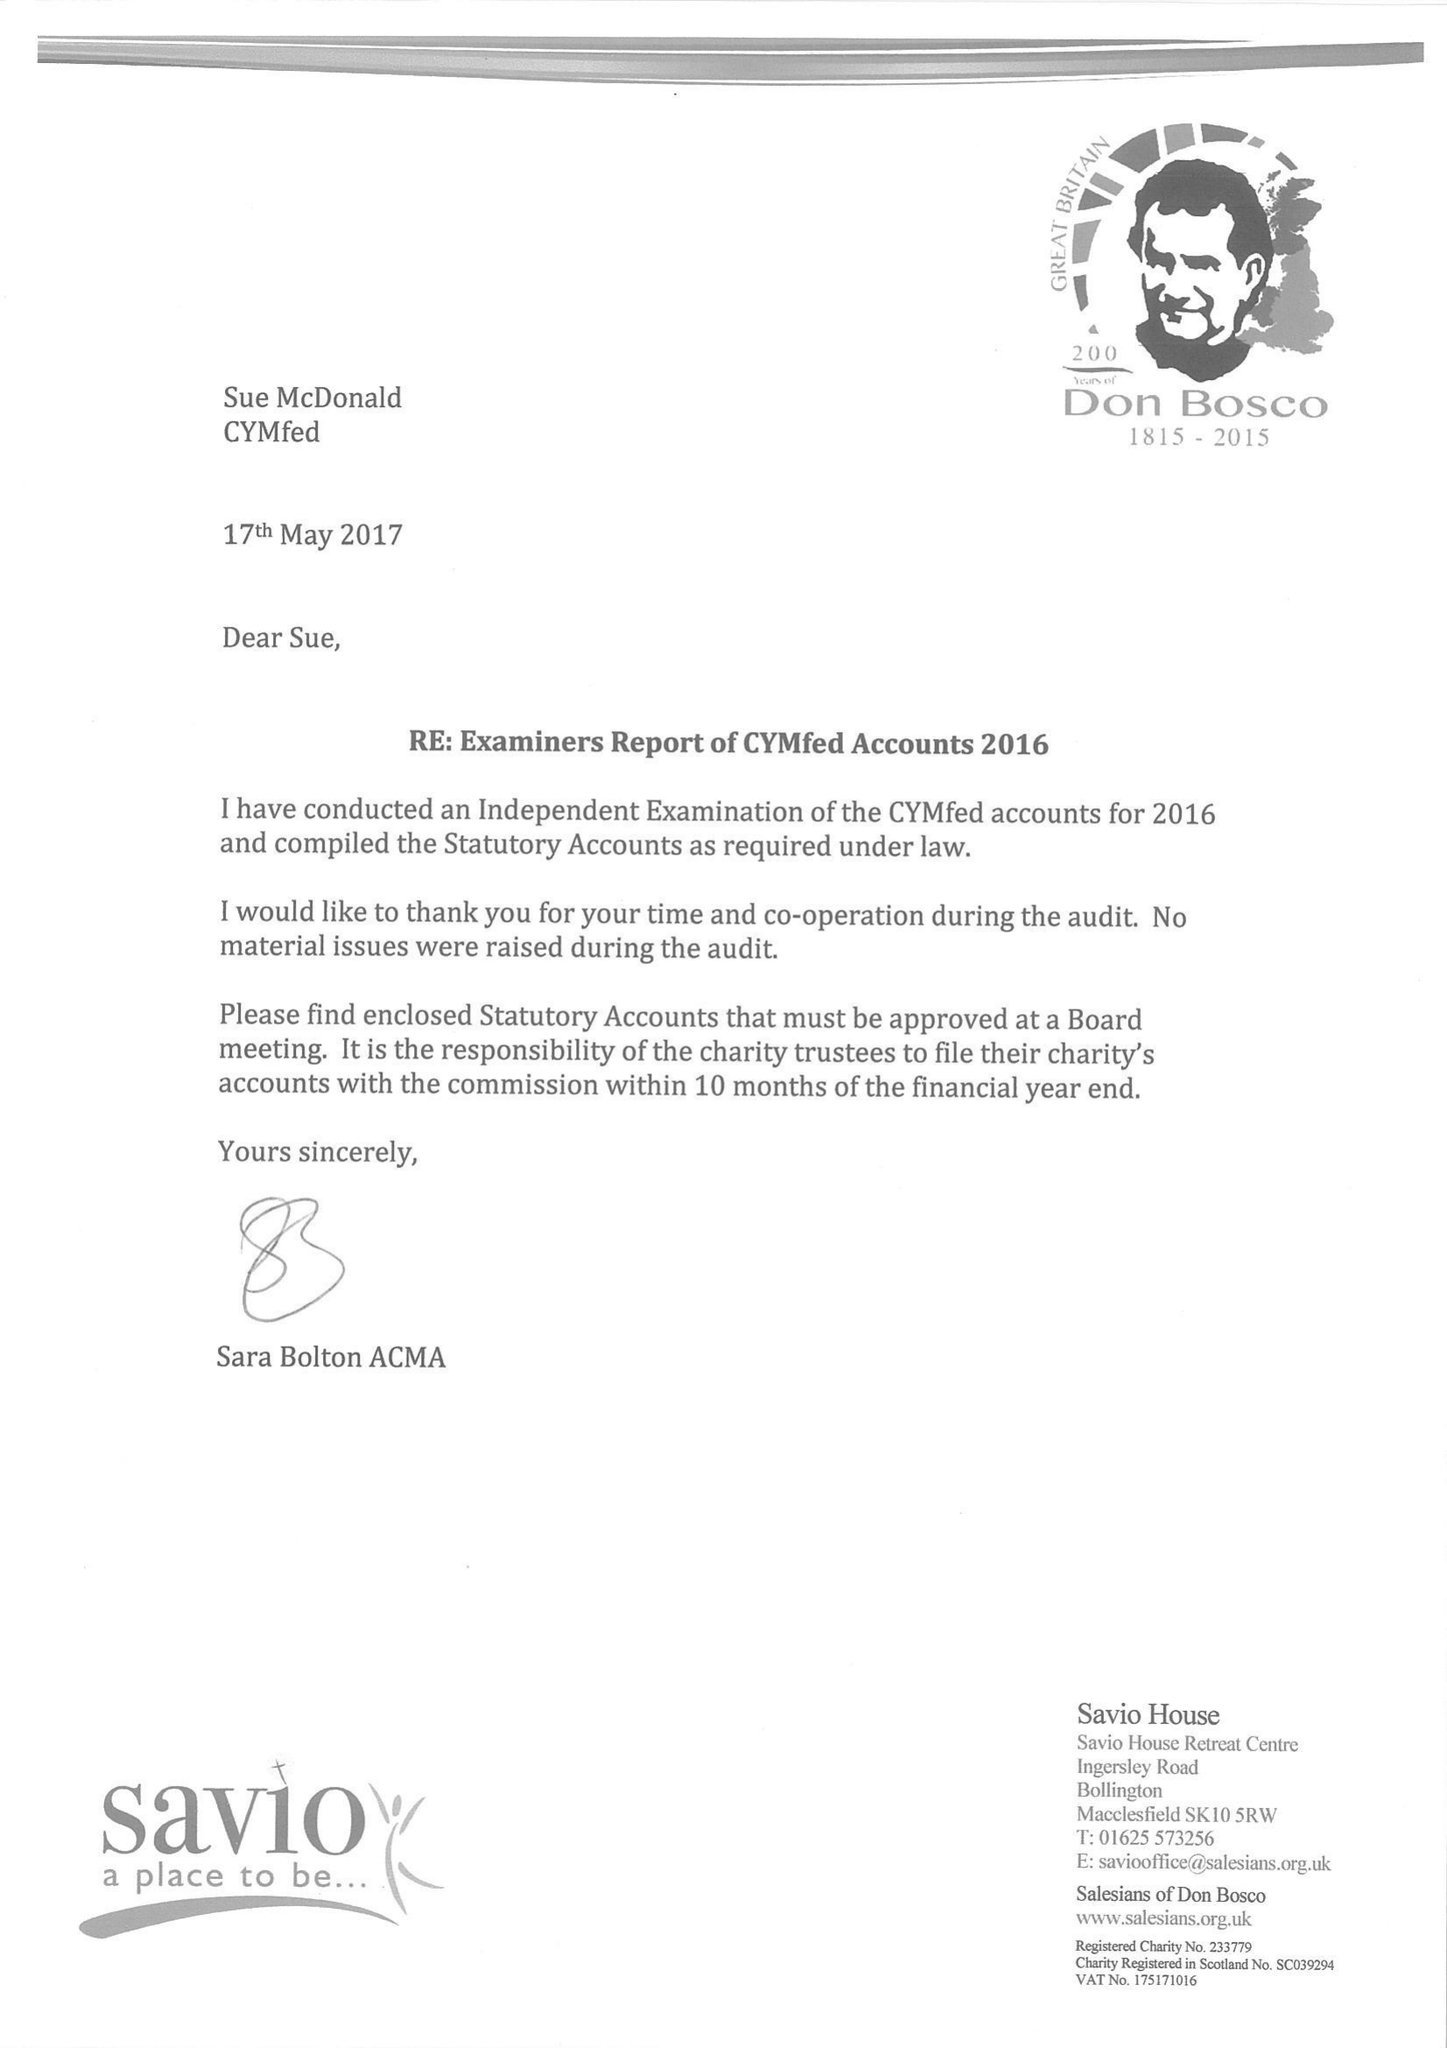What is the value for the address__postcode?
Answer the question using a single word or phrase. SW1V 1BX 